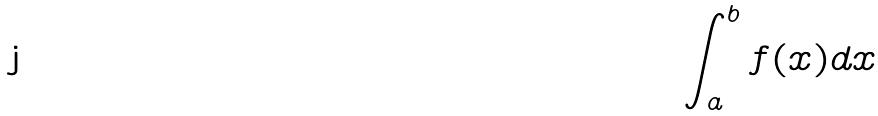Convert formula to latex. <formula><loc_0><loc_0><loc_500><loc_500>\int _ { a } ^ { b } f ( x ) d x</formula> 